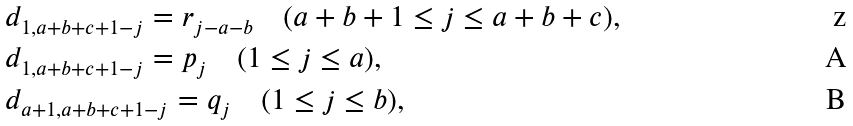Convert formula to latex. <formula><loc_0><loc_0><loc_500><loc_500>& d _ { 1 , a + b + c + 1 - j } = r _ { j - a - b } \quad ( a + b + 1 \leq j \leq a + b + c ) , \\ & d _ { 1 , a + b + c + 1 - j } = p _ { j } \quad ( 1 \leq j \leq a ) , \\ & d _ { a + 1 , a + b + c + 1 - j } = q _ { j } \quad ( 1 \leq j \leq b ) ,</formula> 